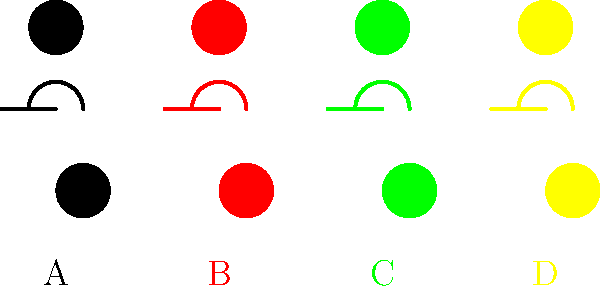Which color combination is most commonly associated with the symbol of the raised fist in the context of the Civil Rights Movement? To answer this question, let's analyze the symbols and their color associations:

1. The raised fist is a symbol of solidarity and support used in various social movements, including the Civil Rights Movement.

2. In the image, we see four color variations of civil rights symbols:
   A. Black
   B. Red
   C. Green
   D. Yellow

3. The black raised fist (option A) is the most iconic and widely recognized symbol associated with the Civil Rights Movement, particularly the Black Power movement of the 1960s and 1970s.

4. The black color symbolizes:
   - African American identity and pride
   - Resistance against oppression
   - Unity and solidarity within the Black community

5. While other colors have been used in various contexts, the black raised fist remains the most potent and recognizable symbol specifically tied to the Civil Rights Movement in the United States.

6. The other colors shown (red, green, and yellow) are more commonly associated with other movements or have different connotations:
   - Red: Often associated with socialist or communist movements
   - Green: Typically linked to environmental or Irish nationalist movements
   - Yellow: Less commonly used in civil rights contexts

Therefore, the black color (option A) is the most appropriate and commonly associated with the raised fist symbol in the context of the Civil Rights Movement.
Answer: Black 